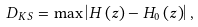<formula> <loc_0><loc_0><loc_500><loc_500>D _ { K S } = \max \left | H \left ( z \right ) - H _ { 0 } \left ( z \right ) \right | ,</formula> 